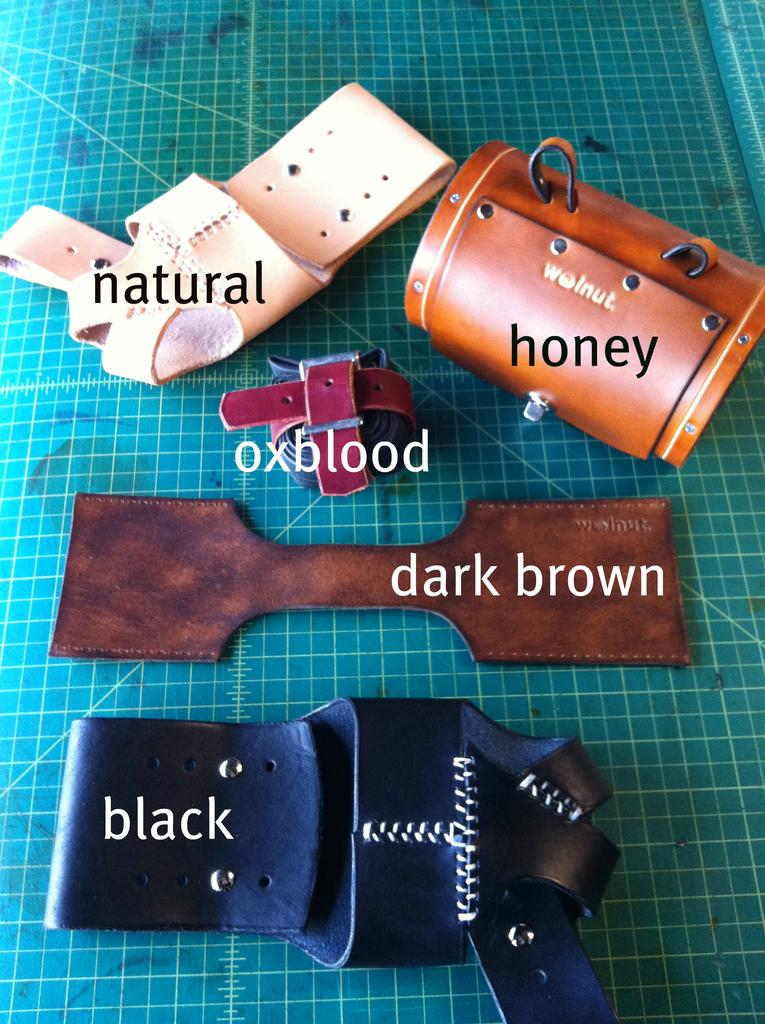What is the main object in the image? There is a box in the image. What can be seen on the surface beneath the objects? There are other objects on a green color surface in the image. Is there any text or writing in the image? Yes, there is something written on the image. Can you see a rat hiding under the box in the image? There is no rat present in the image. What type of scarecrow is standing next to the box in the image? There is no scarecrow present in the image. 